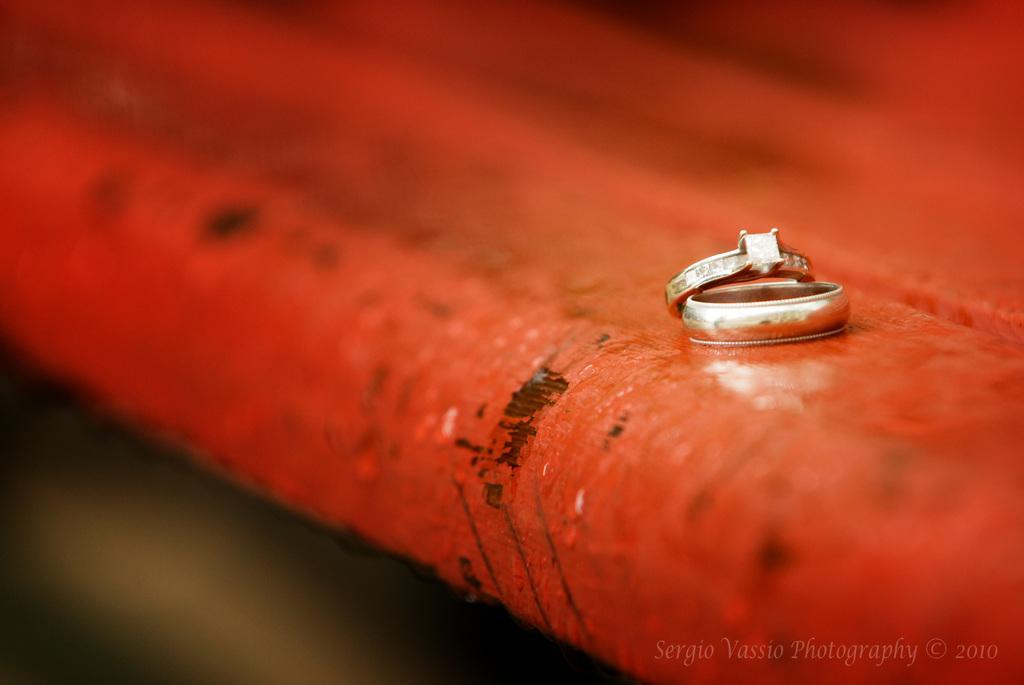How would you summarize this image in a sentence or two? On the right side there are two rings on a red surface. The background is blurred. In the bottom right-hand corner there is some text. 